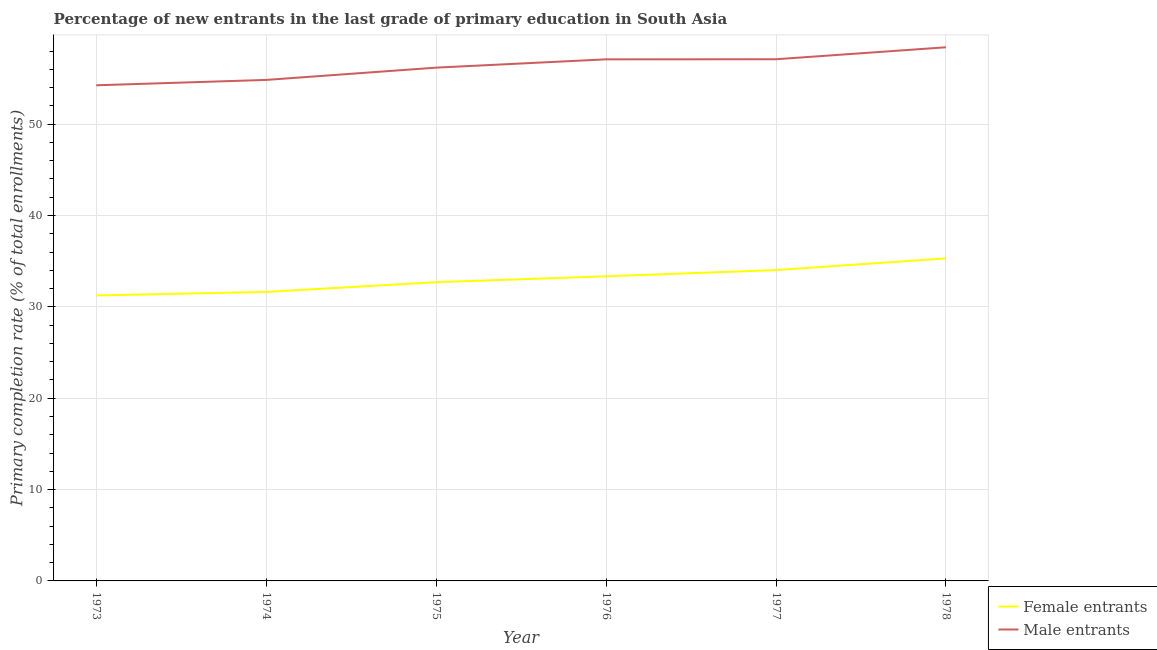How many different coloured lines are there?
Give a very brief answer. 2. What is the primary completion rate of female entrants in 1973?
Keep it short and to the point. 31.25. Across all years, what is the maximum primary completion rate of male entrants?
Offer a terse response. 58.41. Across all years, what is the minimum primary completion rate of female entrants?
Offer a very short reply. 31.25. In which year was the primary completion rate of male entrants maximum?
Your response must be concise. 1978. In which year was the primary completion rate of female entrants minimum?
Offer a terse response. 1973. What is the total primary completion rate of male entrants in the graph?
Keep it short and to the point. 337.89. What is the difference between the primary completion rate of female entrants in 1973 and that in 1974?
Ensure brevity in your answer.  -0.38. What is the difference between the primary completion rate of male entrants in 1976 and the primary completion rate of female entrants in 1975?
Your response must be concise. 24.39. What is the average primary completion rate of male entrants per year?
Provide a succinct answer. 56.31. In the year 1976, what is the difference between the primary completion rate of female entrants and primary completion rate of male entrants?
Your answer should be compact. -23.75. What is the ratio of the primary completion rate of female entrants in 1975 to that in 1977?
Offer a terse response. 0.96. Is the primary completion rate of female entrants in 1974 less than that in 1977?
Your answer should be very brief. Yes. What is the difference between the highest and the second highest primary completion rate of male entrants?
Provide a short and direct response. 1.31. What is the difference between the highest and the lowest primary completion rate of male entrants?
Provide a short and direct response. 4.16. In how many years, is the primary completion rate of female entrants greater than the average primary completion rate of female entrants taken over all years?
Keep it short and to the point. 3. Is the sum of the primary completion rate of male entrants in 1973 and 1974 greater than the maximum primary completion rate of female entrants across all years?
Offer a terse response. Yes. Is the primary completion rate of female entrants strictly greater than the primary completion rate of male entrants over the years?
Your answer should be compact. No. How many years are there in the graph?
Offer a terse response. 6. What is the difference between two consecutive major ticks on the Y-axis?
Offer a very short reply. 10. Where does the legend appear in the graph?
Provide a short and direct response. Bottom right. How many legend labels are there?
Ensure brevity in your answer.  2. How are the legend labels stacked?
Offer a very short reply. Vertical. What is the title of the graph?
Keep it short and to the point. Percentage of new entrants in the last grade of primary education in South Asia. What is the label or title of the Y-axis?
Ensure brevity in your answer.  Primary completion rate (% of total enrollments). What is the Primary completion rate (% of total enrollments) in Female entrants in 1973?
Ensure brevity in your answer.  31.25. What is the Primary completion rate (% of total enrollments) in Male entrants in 1973?
Your answer should be very brief. 54.25. What is the Primary completion rate (% of total enrollments) in Female entrants in 1974?
Offer a very short reply. 31.63. What is the Primary completion rate (% of total enrollments) of Male entrants in 1974?
Give a very brief answer. 54.84. What is the Primary completion rate (% of total enrollments) of Female entrants in 1975?
Your response must be concise. 32.7. What is the Primary completion rate (% of total enrollments) in Male entrants in 1975?
Keep it short and to the point. 56.18. What is the Primary completion rate (% of total enrollments) of Female entrants in 1976?
Make the answer very short. 33.34. What is the Primary completion rate (% of total enrollments) of Male entrants in 1976?
Offer a very short reply. 57.09. What is the Primary completion rate (% of total enrollments) in Female entrants in 1977?
Give a very brief answer. 34.03. What is the Primary completion rate (% of total enrollments) of Male entrants in 1977?
Give a very brief answer. 57.1. What is the Primary completion rate (% of total enrollments) in Female entrants in 1978?
Provide a succinct answer. 35.31. What is the Primary completion rate (% of total enrollments) in Male entrants in 1978?
Provide a short and direct response. 58.41. Across all years, what is the maximum Primary completion rate (% of total enrollments) of Female entrants?
Your response must be concise. 35.31. Across all years, what is the maximum Primary completion rate (% of total enrollments) in Male entrants?
Your answer should be compact. 58.41. Across all years, what is the minimum Primary completion rate (% of total enrollments) of Female entrants?
Keep it short and to the point. 31.25. Across all years, what is the minimum Primary completion rate (% of total enrollments) in Male entrants?
Offer a terse response. 54.25. What is the total Primary completion rate (% of total enrollments) in Female entrants in the graph?
Offer a terse response. 198.26. What is the total Primary completion rate (% of total enrollments) of Male entrants in the graph?
Make the answer very short. 337.89. What is the difference between the Primary completion rate (% of total enrollments) of Female entrants in 1973 and that in 1974?
Offer a terse response. -0.38. What is the difference between the Primary completion rate (% of total enrollments) in Male entrants in 1973 and that in 1974?
Your answer should be compact. -0.59. What is the difference between the Primary completion rate (% of total enrollments) in Female entrants in 1973 and that in 1975?
Offer a terse response. -1.45. What is the difference between the Primary completion rate (% of total enrollments) of Male entrants in 1973 and that in 1975?
Make the answer very short. -1.93. What is the difference between the Primary completion rate (% of total enrollments) of Female entrants in 1973 and that in 1976?
Provide a short and direct response. -2.09. What is the difference between the Primary completion rate (% of total enrollments) in Male entrants in 1973 and that in 1976?
Provide a short and direct response. -2.84. What is the difference between the Primary completion rate (% of total enrollments) of Female entrants in 1973 and that in 1977?
Offer a terse response. -2.78. What is the difference between the Primary completion rate (% of total enrollments) of Male entrants in 1973 and that in 1977?
Give a very brief answer. -2.85. What is the difference between the Primary completion rate (% of total enrollments) of Female entrants in 1973 and that in 1978?
Offer a very short reply. -4.05. What is the difference between the Primary completion rate (% of total enrollments) in Male entrants in 1973 and that in 1978?
Your answer should be compact. -4.16. What is the difference between the Primary completion rate (% of total enrollments) of Female entrants in 1974 and that in 1975?
Your response must be concise. -1.07. What is the difference between the Primary completion rate (% of total enrollments) of Male entrants in 1974 and that in 1975?
Your answer should be very brief. -1.34. What is the difference between the Primary completion rate (% of total enrollments) in Female entrants in 1974 and that in 1976?
Provide a succinct answer. -1.71. What is the difference between the Primary completion rate (% of total enrollments) in Male entrants in 1974 and that in 1976?
Your response must be concise. -2.25. What is the difference between the Primary completion rate (% of total enrollments) of Female entrants in 1974 and that in 1977?
Provide a short and direct response. -2.39. What is the difference between the Primary completion rate (% of total enrollments) of Male entrants in 1974 and that in 1977?
Your answer should be compact. -2.26. What is the difference between the Primary completion rate (% of total enrollments) in Female entrants in 1974 and that in 1978?
Make the answer very short. -3.67. What is the difference between the Primary completion rate (% of total enrollments) in Male entrants in 1974 and that in 1978?
Ensure brevity in your answer.  -3.57. What is the difference between the Primary completion rate (% of total enrollments) in Female entrants in 1975 and that in 1976?
Offer a very short reply. -0.64. What is the difference between the Primary completion rate (% of total enrollments) in Male entrants in 1975 and that in 1976?
Your answer should be very brief. -0.91. What is the difference between the Primary completion rate (% of total enrollments) of Female entrants in 1975 and that in 1977?
Give a very brief answer. -1.33. What is the difference between the Primary completion rate (% of total enrollments) of Male entrants in 1975 and that in 1977?
Offer a very short reply. -0.92. What is the difference between the Primary completion rate (% of total enrollments) in Female entrants in 1975 and that in 1978?
Provide a short and direct response. -2.61. What is the difference between the Primary completion rate (% of total enrollments) in Male entrants in 1975 and that in 1978?
Provide a short and direct response. -2.23. What is the difference between the Primary completion rate (% of total enrollments) in Female entrants in 1976 and that in 1977?
Keep it short and to the point. -0.68. What is the difference between the Primary completion rate (% of total enrollments) in Male entrants in 1976 and that in 1977?
Provide a succinct answer. -0.01. What is the difference between the Primary completion rate (% of total enrollments) of Female entrants in 1976 and that in 1978?
Keep it short and to the point. -1.96. What is the difference between the Primary completion rate (% of total enrollments) in Male entrants in 1976 and that in 1978?
Your answer should be compact. -1.32. What is the difference between the Primary completion rate (% of total enrollments) of Female entrants in 1977 and that in 1978?
Your response must be concise. -1.28. What is the difference between the Primary completion rate (% of total enrollments) in Male entrants in 1977 and that in 1978?
Your answer should be compact. -1.31. What is the difference between the Primary completion rate (% of total enrollments) of Female entrants in 1973 and the Primary completion rate (% of total enrollments) of Male entrants in 1974?
Provide a short and direct response. -23.59. What is the difference between the Primary completion rate (% of total enrollments) of Female entrants in 1973 and the Primary completion rate (% of total enrollments) of Male entrants in 1975?
Provide a succinct answer. -24.93. What is the difference between the Primary completion rate (% of total enrollments) in Female entrants in 1973 and the Primary completion rate (% of total enrollments) in Male entrants in 1976?
Give a very brief answer. -25.84. What is the difference between the Primary completion rate (% of total enrollments) of Female entrants in 1973 and the Primary completion rate (% of total enrollments) of Male entrants in 1977?
Give a very brief answer. -25.85. What is the difference between the Primary completion rate (% of total enrollments) in Female entrants in 1973 and the Primary completion rate (% of total enrollments) in Male entrants in 1978?
Provide a short and direct response. -27.16. What is the difference between the Primary completion rate (% of total enrollments) in Female entrants in 1974 and the Primary completion rate (% of total enrollments) in Male entrants in 1975?
Make the answer very short. -24.55. What is the difference between the Primary completion rate (% of total enrollments) of Female entrants in 1974 and the Primary completion rate (% of total enrollments) of Male entrants in 1976?
Offer a terse response. -25.46. What is the difference between the Primary completion rate (% of total enrollments) in Female entrants in 1974 and the Primary completion rate (% of total enrollments) in Male entrants in 1977?
Provide a short and direct response. -25.47. What is the difference between the Primary completion rate (% of total enrollments) in Female entrants in 1974 and the Primary completion rate (% of total enrollments) in Male entrants in 1978?
Keep it short and to the point. -26.78. What is the difference between the Primary completion rate (% of total enrollments) in Female entrants in 1975 and the Primary completion rate (% of total enrollments) in Male entrants in 1976?
Make the answer very short. -24.39. What is the difference between the Primary completion rate (% of total enrollments) in Female entrants in 1975 and the Primary completion rate (% of total enrollments) in Male entrants in 1977?
Keep it short and to the point. -24.4. What is the difference between the Primary completion rate (% of total enrollments) in Female entrants in 1975 and the Primary completion rate (% of total enrollments) in Male entrants in 1978?
Offer a terse response. -25.71. What is the difference between the Primary completion rate (% of total enrollments) in Female entrants in 1976 and the Primary completion rate (% of total enrollments) in Male entrants in 1977?
Your response must be concise. -23.76. What is the difference between the Primary completion rate (% of total enrollments) in Female entrants in 1976 and the Primary completion rate (% of total enrollments) in Male entrants in 1978?
Keep it short and to the point. -25.07. What is the difference between the Primary completion rate (% of total enrollments) of Female entrants in 1977 and the Primary completion rate (% of total enrollments) of Male entrants in 1978?
Your response must be concise. -24.39. What is the average Primary completion rate (% of total enrollments) in Female entrants per year?
Your response must be concise. 33.04. What is the average Primary completion rate (% of total enrollments) in Male entrants per year?
Provide a short and direct response. 56.31. In the year 1973, what is the difference between the Primary completion rate (% of total enrollments) of Female entrants and Primary completion rate (% of total enrollments) of Male entrants?
Your answer should be compact. -23. In the year 1974, what is the difference between the Primary completion rate (% of total enrollments) of Female entrants and Primary completion rate (% of total enrollments) of Male entrants?
Provide a succinct answer. -23.21. In the year 1975, what is the difference between the Primary completion rate (% of total enrollments) of Female entrants and Primary completion rate (% of total enrollments) of Male entrants?
Provide a succinct answer. -23.48. In the year 1976, what is the difference between the Primary completion rate (% of total enrollments) of Female entrants and Primary completion rate (% of total enrollments) of Male entrants?
Keep it short and to the point. -23.75. In the year 1977, what is the difference between the Primary completion rate (% of total enrollments) of Female entrants and Primary completion rate (% of total enrollments) of Male entrants?
Provide a succinct answer. -23.08. In the year 1978, what is the difference between the Primary completion rate (% of total enrollments) in Female entrants and Primary completion rate (% of total enrollments) in Male entrants?
Keep it short and to the point. -23.11. What is the ratio of the Primary completion rate (% of total enrollments) in Female entrants in 1973 to that in 1974?
Keep it short and to the point. 0.99. What is the ratio of the Primary completion rate (% of total enrollments) of Male entrants in 1973 to that in 1974?
Your answer should be compact. 0.99. What is the ratio of the Primary completion rate (% of total enrollments) in Female entrants in 1973 to that in 1975?
Offer a very short reply. 0.96. What is the ratio of the Primary completion rate (% of total enrollments) in Male entrants in 1973 to that in 1975?
Your answer should be very brief. 0.97. What is the ratio of the Primary completion rate (% of total enrollments) in Female entrants in 1973 to that in 1976?
Provide a succinct answer. 0.94. What is the ratio of the Primary completion rate (% of total enrollments) of Male entrants in 1973 to that in 1976?
Make the answer very short. 0.95. What is the ratio of the Primary completion rate (% of total enrollments) in Female entrants in 1973 to that in 1977?
Your answer should be very brief. 0.92. What is the ratio of the Primary completion rate (% of total enrollments) in Male entrants in 1973 to that in 1977?
Provide a succinct answer. 0.95. What is the ratio of the Primary completion rate (% of total enrollments) in Female entrants in 1973 to that in 1978?
Your answer should be very brief. 0.89. What is the ratio of the Primary completion rate (% of total enrollments) in Male entrants in 1973 to that in 1978?
Provide a short and direct response. 0.93. What is the ratio of the Primary completion rate (% of total enrollments) of Female entrants in 1974 to that in 1975?
Your answer should be compact. 0.97. What is the ratio of the Primary completion rate (% of total enrollments) of Male entrants in 1974 to that in 1975?
Your response must be concise. 0.98. What is the ratio of the Primary completion rate (% of total enrollments) of Female entrants in 1974 to that in 1976?
Offer a very short reply. 0.95. What is the ratio of the Primary completion rate (% of total enrollments) in Male entrants in 1974 to that in 1976?
Ensure brevity in your answer.  0.96. What is the ratio of the Primary completion rate (% of total enrollments) in Female entrants in 1974 to that in 1977?
Ensure brevity in your answer.  0.93. What is the ratio of the Primary completion rate (% of total enrollments) of Male entrants in 1974 to that in 1977?
Offer a very short reply. 0.96. What is the ratio of the Primary completion rate (% of total enrollments) of Female entrants in 1974 to that in 1978?
Ensure brevity in your answer.  0.9. What is the ratio of the Primary completion rate (% of total enrollments) of Male entrants in 1974 to that in 1978?
Your response must be concise. 0.94. What is the ratio of the Primary completion rate (% of total enrollments) in Female entrants in 1975 to that in 1976?
Your answer should be compact. 0.98. What is the ratio of the Primary completion rate (% of total enrollments) in Male entrants in 1975 to that in 1976?
Offer a very short reply. 0.98. What is the ratio of the Primary completion rate (% of total enrollments) of Male entrants in 1975 to that in 1977?
Provide a succinct answer. 0.98. What is the ratio of the Primary completion rate (% of total enrollments) of Female entrants in 1975 to that in 1978?
Give a very brief answer. 0.93. What is the ratio of the Primary completion rate (% of total enrollments) of Male entrants in 1975 to that in 1978?
Keep it short and to the point. 0.96. What is the ratio of the Primary completion rate (% of total enrollments) in Female entrants in 1976 to that in 1977?
Offer a terse response. 0.98. What is the ratio of the Primary completion rate (% of total enrollments) of Male entrants in 1976 to that in 1978?
Provide a succinct answer. 0.98. What is the ratio of the Primary completion rate (% of total enrollments) of Female entrants in 1977 to that in 1978?
Give a very brief answer. 0.96. What is the ratio of the Primary completion rate (% of total enrollments) of Male entrants in 1977 to that in 1978?
Offer a very short reply. 0.98. What is the difference between the highest and the second highest Primary completion rate (% of total enrollments) of Female entrants?
Give a very brief answer. 1.28. What is the difference between the highest and the second highest Primary completion rate (% of total enrollments) of Male entrants?
Offer a terse response. 1.31. What is the difference between the highest and the lowest Primary completion rate (% of total enrollments) in Female entrants?
Keep it short and to the point. 4.05. What is the difference between the highest and the lowest Primary completion rate (% of total enrollments) of Male entrants?
Your response must be concise. 4.16. 